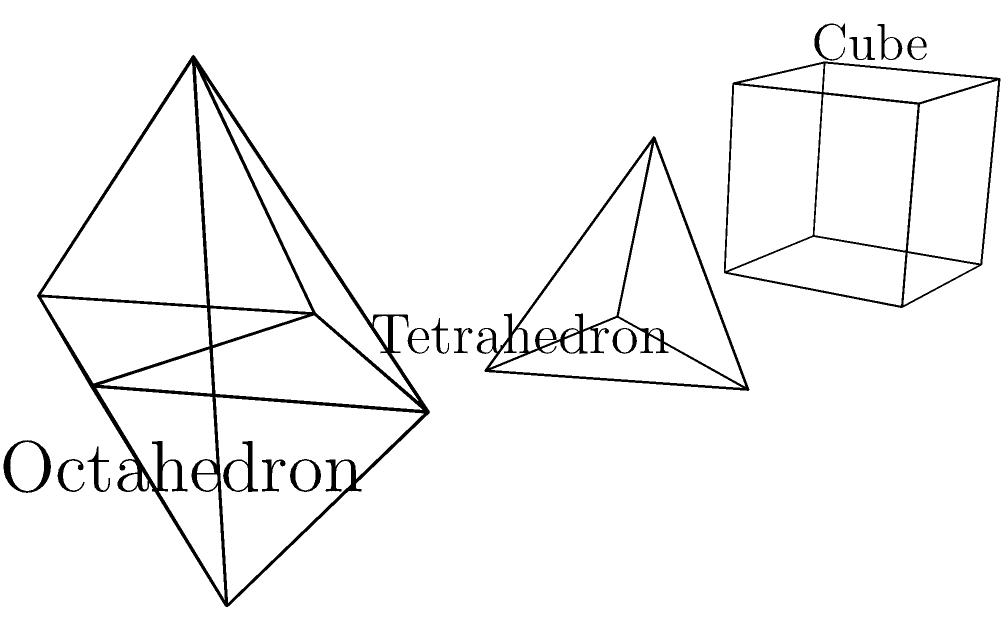Consider the three polyhedra shown in the image: a cube, a tetrahedron, and an octahedron. Calculate the Euler characteristic for each polyhedron and explain its significance in topology. How does this relate to the classification of surfaces? To solve this problem, let's follow these steps:

1. Recall the Euler characteristic formula:
   $$\chi = V - E + F$$
   where $V$ is the number of vertices, $E$ is the number of edges, and $F$ is the number of faces.

2. Calculate the Euler characteristic for each polyhedron:

   a) Cube:
      $V = 8$, $E = 12$, $F = 6$
      $\chi = 8 - 12 + 6 = 2$

   b) Tetrahedron:
      $V = 4$, $E = 6$, $F = 4$
      $\chi = 4 - 6 + 4 = 2$

   c) Octahedron:
      $V = 6$, $E = 12$, $F = 8$
      $\chi = 6 - 12 + 8 = 2$

3. Significance in topology:
   The Euler characteristic is a topological invariant, meaning it remains constant under continuous deformations of the surface. All convex polyhedra have an Euler characteristic of 2, which is the same as that of a sphere.

4. Relation to classification of surfaces:
   The Euler characteristic plays a crucial role in the classification of surfaces. For orientable closed surfaces, the Euler characteristic is related to the genus $g$ (number of holes) by the formula:
   $$\chi = 2 - 2g$$

   For example:
   - Sphere: $\chi = 2$, $g = 0$
   - Torus: $\chi = 0$, $g = 1$
   - Double torus: $\chi = -2$, $g = 2$

   This relationship allows topologists to classify surfaces based on their Euler characteristic and orientability.

5. The Euler characteristic is also related to the Gauss-Bonnet theorem, which connects the geometry of a surface to its topology:
   $$\int_M K dA = 2\pi\chi$$
   where $K$ is the Gaussian curvature and $dA$ is the area element of the surface $M$.

In conclusion, the Euler characteristic of 2 for all these polyhedra indicates that they are topologically equivalent to a sphere, demonstrating the power of this concept in classifying and understanding the fundamental properties of geometric shapes and surfaces.
Answer: Euler characteristic is 2 for all three polyhedra; topological invariant indicating sphere-like surfaces; crucial for surface classification and linked to genus by $\chi = 2 - 2g$. 